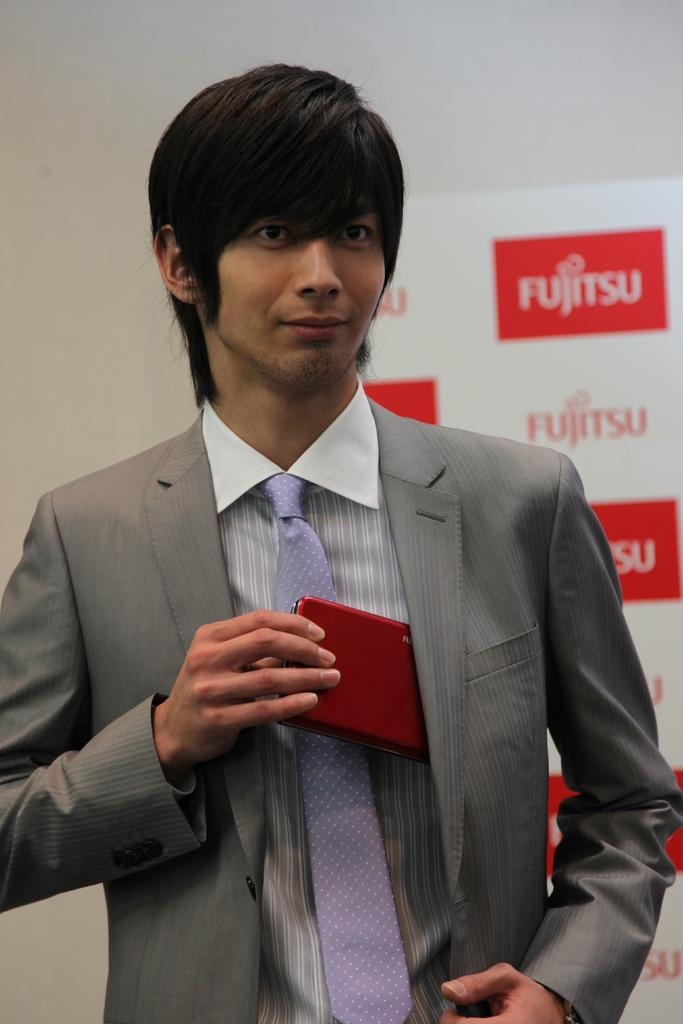Who is the main subject in the image? There is a man in the center of the image. What is the man holding in his hand? The man is holding a mobile in his hand. What can be seen in the background of the image? There is a poster in the background of the image. What type of lunchroom can be seen in the image? There is no lunchroom present in the image. What material is the man using to lead the group in the image? The man is not leading a group, and there is no indication of any material being used for leading. 